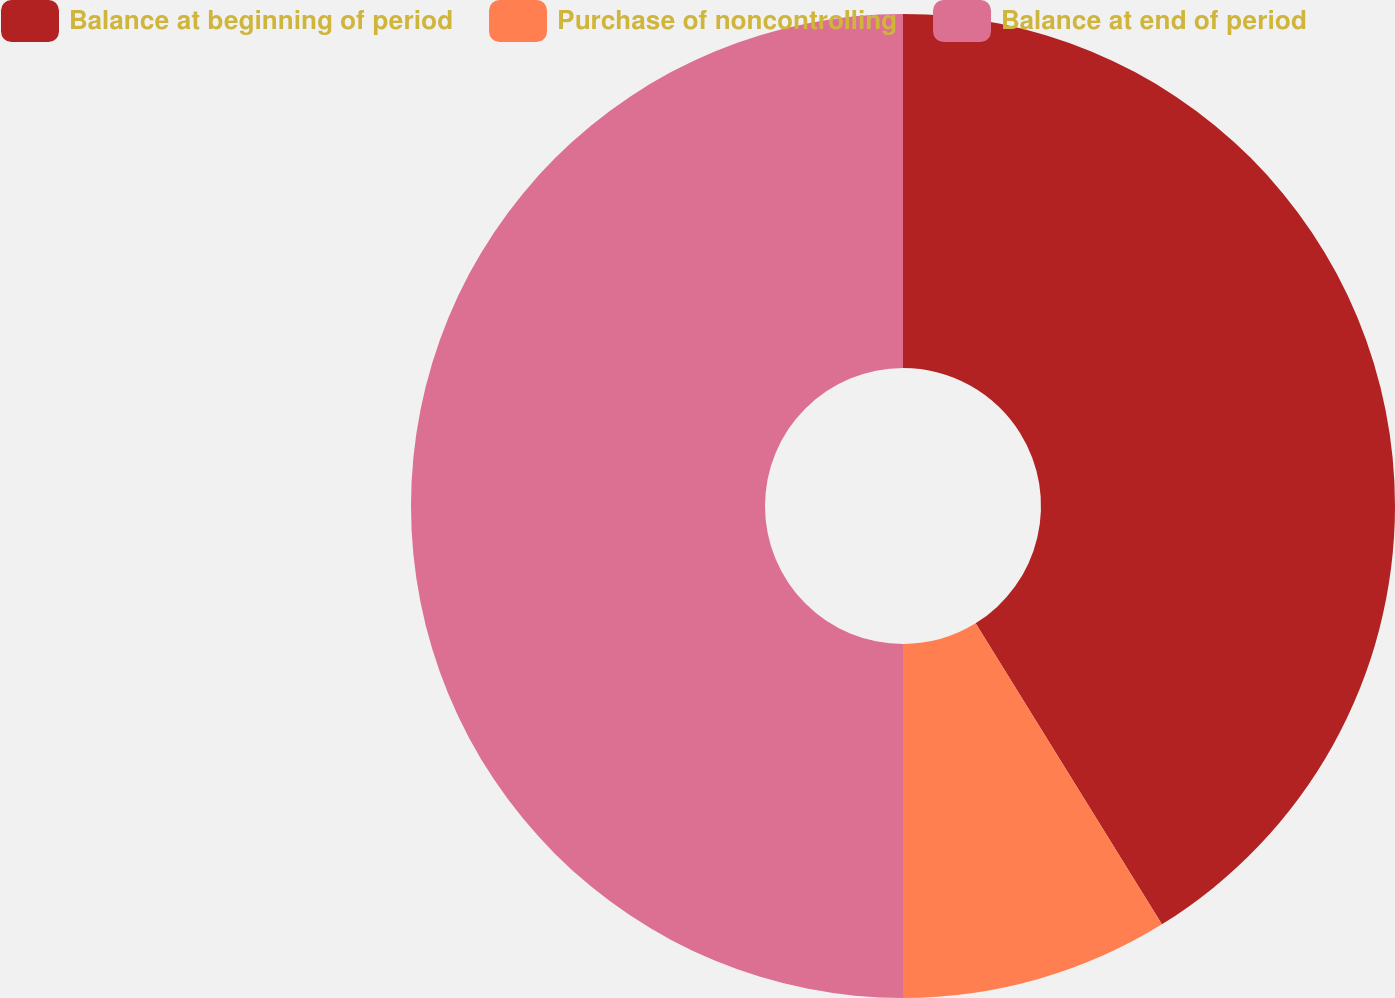Convert chart. <chart><loc_0><loc_0><loc_500><loc_500><pie_chart><fcel>Balance at beginning of period<fcel>Purchase of noncontrolling<fcel>Balance at end of period<nl><fcel>41.18%<fcel>8.82%<fcel>50.0%<nl></chart> 